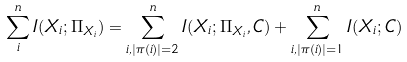Convert formula to latex. <formula><loc_0><loc_0><loc_500><loc_500>\sum _ { i } ^ { n } I ( X _ { i } ; \Pi _ { X _ { i } } ) = \sum _ { i , | \pi ( i ) | = 2 } ^ { n } I ( X _ { i } ; \Pi _ { X _ { i } } , C ) + \sum _ { i , | \pi ( i ) | = 1 } ^ { n } I ( X _ { i } ; C )</formula> 